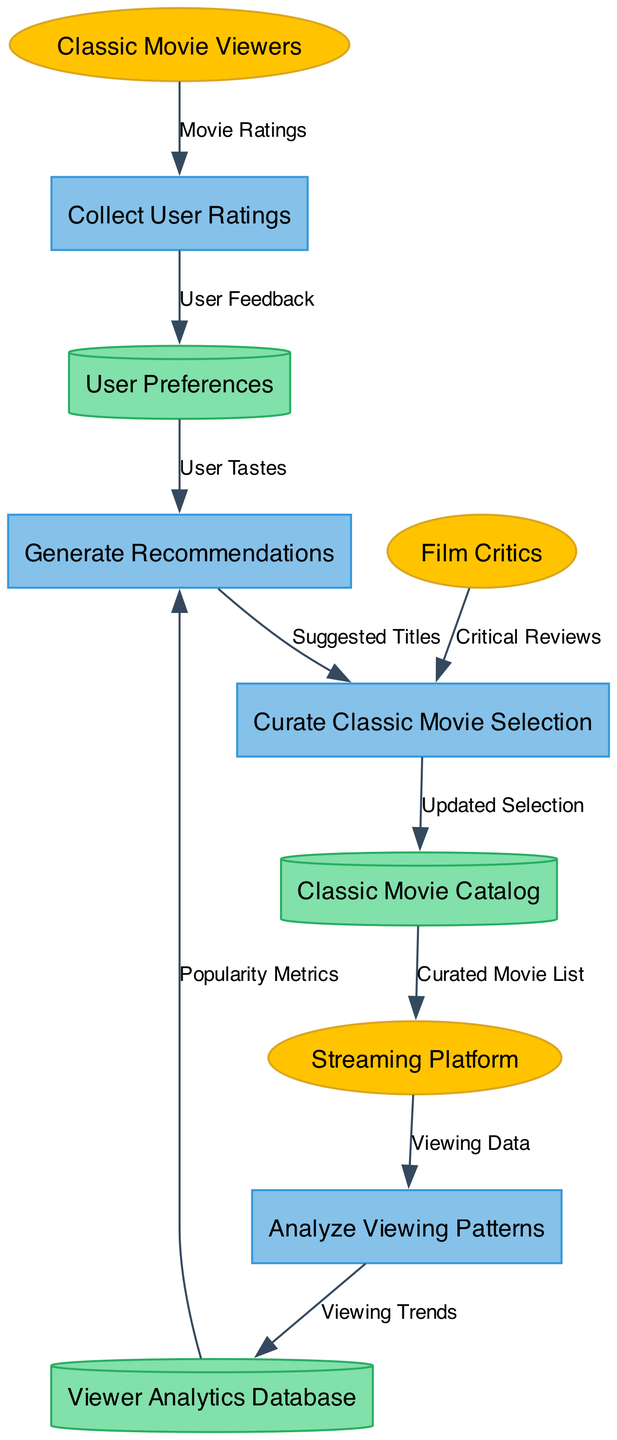What are the external entities represented in the diagram? The external entities are listed directly in the diagram as separate nodes. By identifying them, we can see that there are three: Classic Movie Viewers, Film Critics, and Streaming Platform. Each of these entities is crucial for the overall process depicted in the data flow.
Answer: Classic Movie Viewers, Film Critics, Streaming Platform How many processes are illustrated in the diagram? The processes are also explicitly defined in the diagram. By counting the number of rectangular nodes labeled with process names, we find that there are four: Analyze Viewing Patterns, Collect User Ratings, Generate Recommendations, and Curate Classic Movie Selection.
Answer: 4 What data flows from the Classic Movie Viewers to the Collect User Ratings process? Looking at the connections in the diagram, we can see that the arrow labeled "Movie Ratings" indicates the flow of data from Classic Movie Viewers to the Collect User Ratings process. It represents the ratings provided by the viewers.
Answer: Movie Ratings Which process receives data from the Viewer Analytics Database? In the diagram, we can trace the data flow from Viewer Analytics Database to the process labeled Generate Recommendations. This shows that the recommendations are based on the metrics that are stored in the database.
Answer: Generate Recommendations Who contributes Critical Reviews to the Curate Classic Movie Selection process? By identifying the source of data for the Curate Classic Movie Selection process, we notice there is a directed flow from Film Critics to the process. This means that critical reviews from Film Critics influence the selection of classic movies.
Answer: Film Critics How many data stores are present in the diagram? We can determine the number of data stores by counting the cylinder-shaped nodes in the diagram, which are designated to hold data. According to the diagram, there are three: Viewer Analytics Database, Classic Movie Catalog, and User Preferences.
Answer: 3 What type of metrics does Generate Recommendations utilize from the Viewer Analytics Database? The data flow labeled "Popularity Metrics" clearly illustrates the specific type of metrics being utilized by the Generate Recommendations process, as it indicates the data that is retrieved from the Viewer Analytics Database.
Answer: Popularity Metrics Which process ultimately sends the Curated Movie List to the Streaming Platform? By following the flow of the diagram, we observe that the process "Curate Classic Movie Selection" sends the curated content to the node representing the Streaming Platform. This indicates that the Streaming Platform receives the final selection of movies.
Answer: Curate Classic Movie Selection 